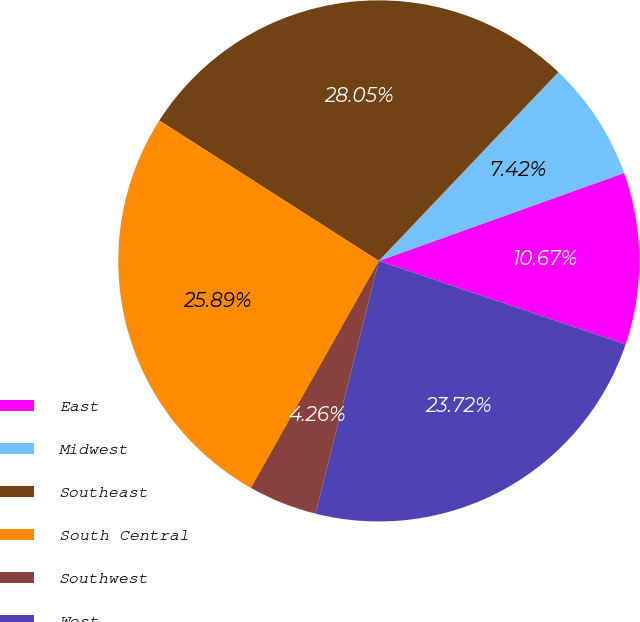Convert chart. <chart><loc_0><loc_0><loc_500><loc_500><pie_chart><fcel>East<fcel>Midwest<fcel>Southeast<fcel>South Central<fcel>Southwest<fcel>West<nl><fcel>10.67%<fcel>7.42%<fcel>28.05%<fcel>25.89%<fcel>4.26%<fcel>23.72%<nl></chart> 